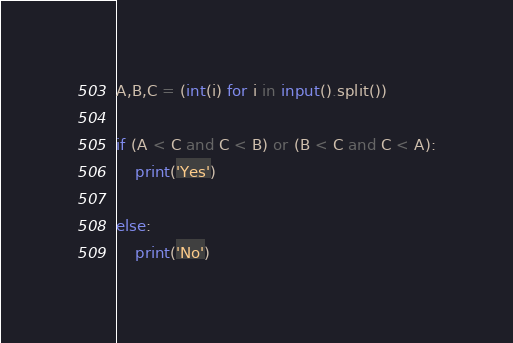<code> <loc_0><loc_0><loc_500><loc_500><_Python_>A,B,C = (int(i) for i in input().split())

if (A < C and C < B) or (B < C and C < A):
    print('Yes')
    
else:
    print('No')</code> 